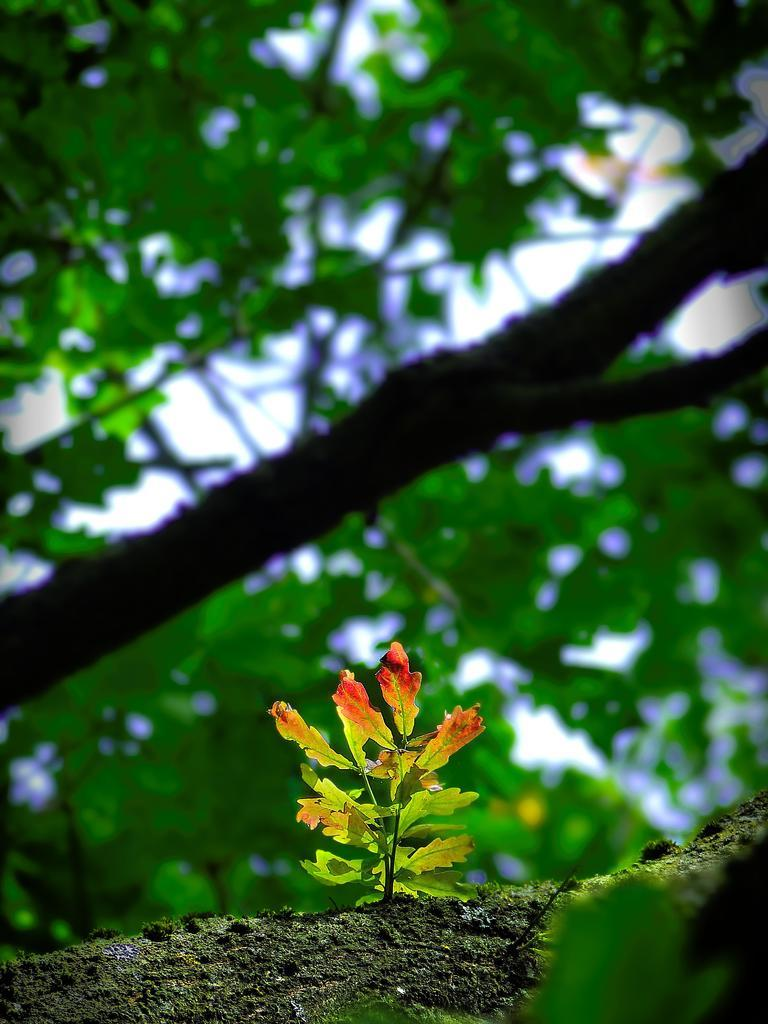What type of vegetation is on the ground in the image? There is a plant on the ground in the image. What is located behind the plant? There is a tree behind the plant. What can be seen in the background of the image? The sky is visible in the background of the image. How would you describe the appearance of the background? The background appears blurry. How does the organization of the plant and tree in the image contribute to the prose of the scene? There is no prose in the image, as it is a visual representation. Additionally, the organization of the plant and tree does not contribute to any literary elements. 